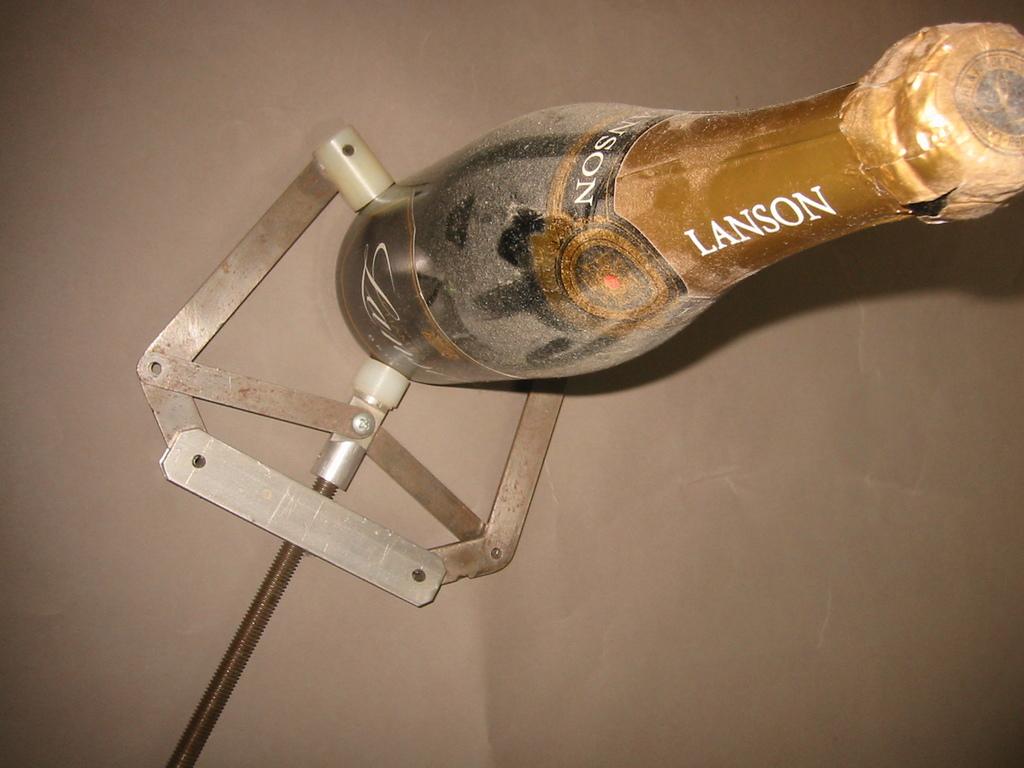What brand of drink is in this bottle?
Ensure brevity in your answer.  Lanson. 